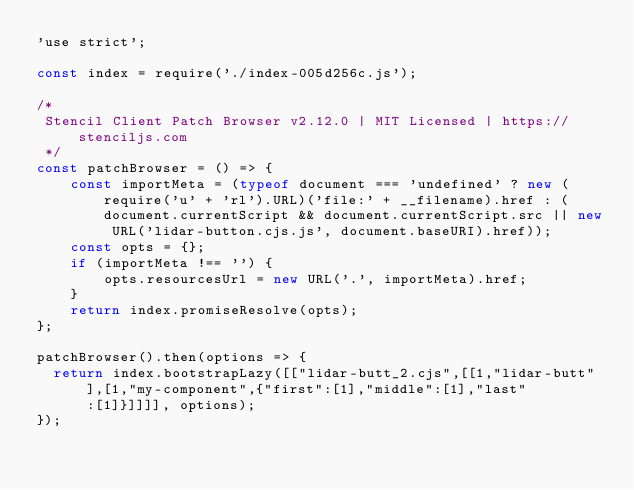<code> <loc_0><loc_0><loc_500><loc_500><_JavaScript_>'use strict';

const index = require('./index-005d256c.js');

/*
 Stencil Client Patch Browser v2.12.0 | MIT Licensed | https://stenciljs.com
 */
const patchBrowser = () => {
    const importMeta = (typeof document === 'undefined' ? new (require('u' + 'rl').URL)('file:' + __filename).href : (document.currentScript && document.currentScript.src || new URL('lidar-button.cjs.js', document.baseURI).href));
    const opts = {};
    if (importMeta !== '') {
        opts.resourcesUrl = new URL('.', importMeta).href;
    }
    return index.promiseResolve(opts);
};

patchBrowser().then(options => {
  return index.bootstrapLazy([["lidar-butt_2.cjs",[[1,"lidar-butt"],[1,"my-component",{"first":[1],"middle":[1],"last":[1]}]]]], options);
});
</code> 